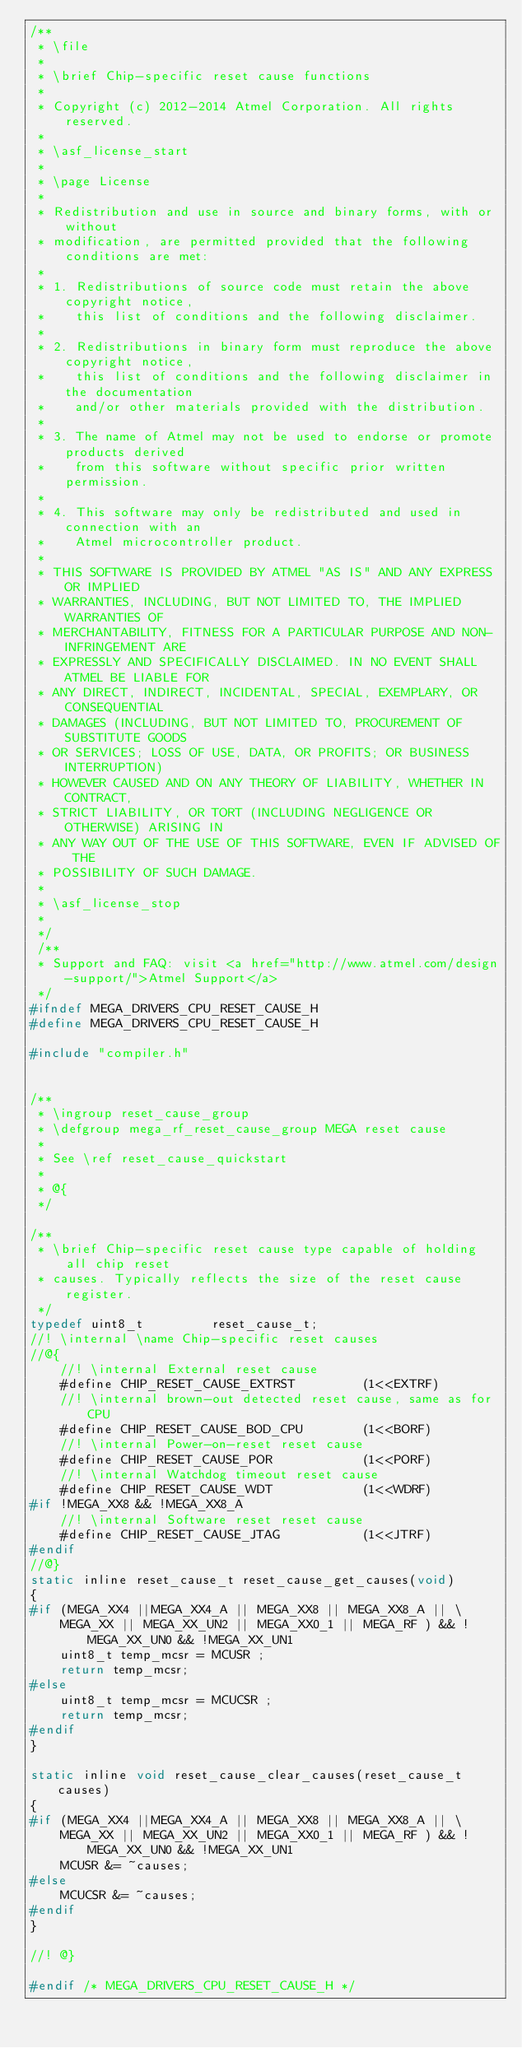Convert code to text. <code><loc_0><loc_0><loc_500><loc_500><_C_>/**
 * \file
 *
 * \brief Chip-specific reset cause functions
 *
 * Copyright (c) 2012-2014 Atmel Corporation. All rights reserved.
 *
 * \asf_license_start
 *
 * \page License
 *
 * Redistribution and use in source and binary forms, with or without
 * modification, are permitted provided that the following conditions are met:
 *
 * 1. Redistributions of source code must retain the above copyright notice,
 *    this list of conditions and the following disclaimer.
 *
 * 2. Redistributions in binary form must reproduce the above copyright notice,
 *    this list of conditions and the following disclaimer in the documentation
 *    and/or other materials provided with the distribution.
 *
 * 3. The name of Atmel may not be used to endorse or promote products derived
 *    from this software without specific prior written permission.
 *
 * 4. This software may only be redistributed and used in connection with an
 *    Atmel microcontroller product.
 *
 * THIS SOFTWARE IS PROVIDED BY ATMEL "AS IS" AND ANY EXPRESS OR IMPLIED
 * WARRANTIES, INCLUDING, BUT NOT LIMITED TO, THE IMPLIED WARRANTIES OF
 * MERCHANTABILITY, FITNESS FOR A PARTICULAR PURPOSE AND NON-INFRINGEMENT ARE
 * EXPRESSLY AND SPECIFICALLY DISCLAIMED. IN NO EVENT SHALL ATMEL BE LIABLE FOR
 * ANY DIRECT, INDIRECT, INCIDENTAL, SPECIAL, EXEMPLARY, OR CONSEQUENTIAL
 * DAMAGES (INCLUDING, BUT NOT LIMITED TO, PROCUREMENT OF SUBSTITUTE GOODS
 * OR SERVICES; LOSS OF USE, DATA, OR PROFITS; OR BUSINESS INTERRUPTION)
 * HOWEVER CAUSED AND ON ANY THEORY OF LIABILITY, WHETHER IN CONTRACT,
 * STRICT LIABILITY, OR TORT (INCLUDING NEGLIGENCE OR OTHERWISE) ARISING IN
 * ANY WAY OUT OF THE USE OF THIS SOFTWARE, EVEN IF ADVISED OF THE
 * POSSIBILITY OF SUCH DAMAGE.
 *
 * \asf_license_stop
 *
 */
 /**
 * Support and FAQ: visit <a href="http://www.atmel.com/design-support/">Atmel Support</a>
 */
#ifndef MEGA_DRIVERS_CPU_RESET_CAUSE_H
#define MEGA_DRIVERS_CPU_RESET_CAUSE_H

#include "compiler.h"


/**
 * \ingroup reset_cause_group
 * \defgroup mega_rf_reset_cause_group MEGA reset cause
 *
 * See \ref reset_cause_quickstart
 *
 * @{
 */

/**
 * \brief Chip-specific reset cause type capable of holding all chip reset
 * causes. Typically reflects the size of the reset cause register.
 */
typedef uint8_t         reset_cause_t;
//! \internal \name Chip-specific reset causes
//@{
	//! \internal External reset cause
	#define CHIP_RESET_CAUSE_EXTRST         (1<<EXTRF)
	//! \internal brown-out detected reset cause, same as for CPU
	#define CHIP_RESET_CAUSE_BOD_CPU        (1<<BORF)
	//! \internal Power-on-reset reset cause
	#define CHIP_RESET_CAUSE_POR            (1<<PORF)
	//! \internal Watchdog timeout reset cause
	#define CHIP_RESET_CAUSE_WDT            (1<<WDRF)
#if !MEGA_XX8 && !MEGA_XX8_A
	//! \internal Software reset reset cause
	#define CHIP_RESET_CAUSE_JTAG           (1<<JTRF)
#endif
//@}
static inline reset_cause_t reset_cause_get_causes(void)
{
#if (MEGA_XX4 ||MEGA_XX4_A || MEGA_XX8 || MEGA_XX8_A || \
	MEGA_XX || MEGA_XX_UN2 || MEGA_XX0_1 || MEGA_RF ) && !MEGA_XX_UN0 && !MEGA_XX_UN1
	uint8_t temp_mcsr = MCUSR ;
	return temp_mcsr;
#else	
	uint8_t temp_mcsr = MCUCSR ;
	return temp_mcsr;
#endif 	
}

static inline void reset_cause_clear_causes(reset_cause_t causes)
{
#if (MEGA_XX4 ||MEGA_XX4_A || MEGA_XX8 || MEGA_XX8_A || \
	MEGA_XX || MEGA_XX_UN2 || MEGA_XX0_1 || MEGA_RF ) && !MEGA_XX_UN0 && !MEGA_XX_UN1
	MCUSR &= ~causes;
#else	
	MCUCSR &= ~causes;
#endif
}

//! @}

#endif /* MEGA_DRIVERS_CPU_RESET_CAUSE_H */
</code> 